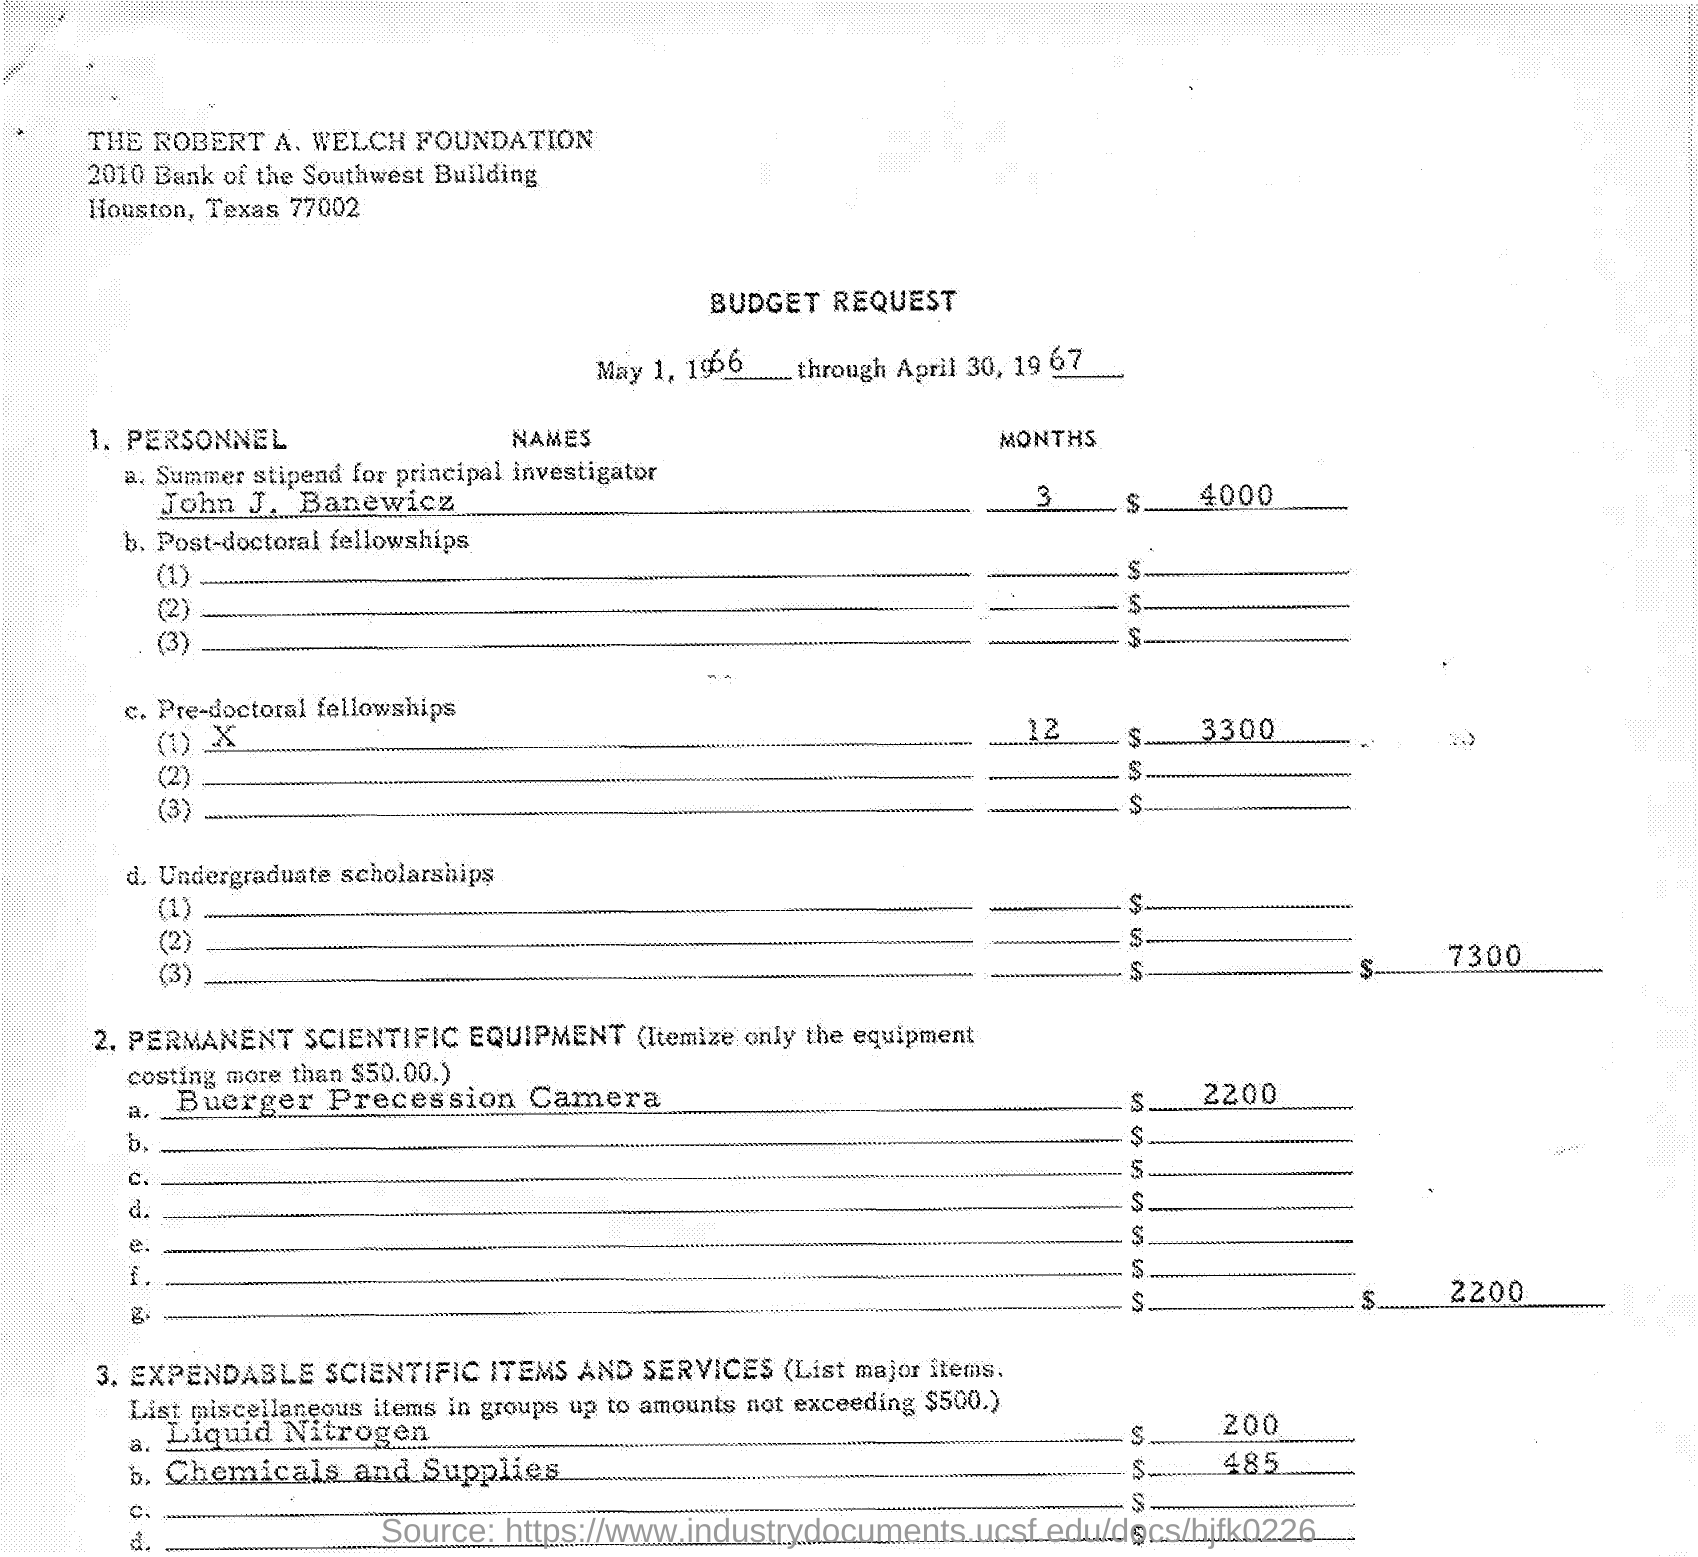Indicate a few pertinent items in this graphic. The cost of liquid nitrogen is currently around 200... The budget for pre-doctoral fellowships is currently set at 3,300. John J. Banewicz will be paid the amount of $4,000 for a period of three months. The period covered by the data is from May 1, 1966 to April 30, 1967. 